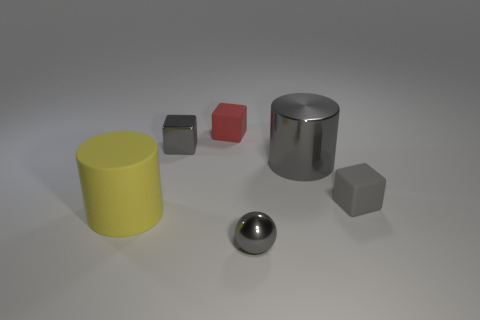Add 2 large red rubber objects. How many objects exist? 8 Subtract all cylinders. How many objects are left? 4 Add 5 tiny things. How many tiny things are left? 9 Add 2 metallic cubes. How many metallic cubes exist? 3 Subtract 0 red balls. How many objects are left? 6 Subtract all metal cubes. Subtract all small gray matte cubes. How many objects are left? 4 